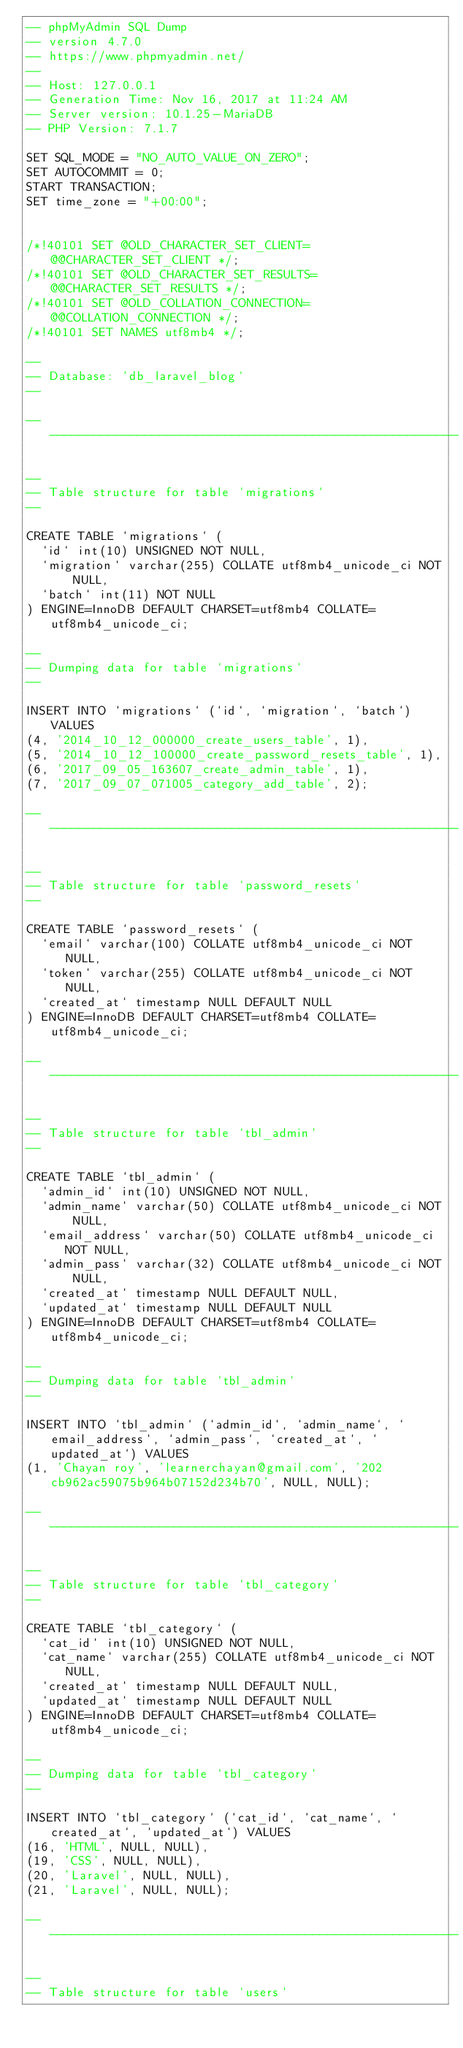<code> <loc_0><loc_0><loc_500><loc_500><_SQL_>-- phpMyAdmin SQL Dump
-- version 4.7.0
-- https://www.phpmyadmin.net/
--
-- Host: 127.0.0.1
-- Generation Time: Nov 16, 2017 at 11:24 AM
-- Server version: 10.1.25-MariaDB
-- PHP Version: 7.1.7

SET SQL_MODE = "NO_AUTO_VALUE_ON_ZERO";
SET AUTOCOMMIT = 0;
START TRANSACTION;
SET time_zone = "+00:00";


/*!40101 SET @OLD_CHARACTER_SET_CLIENT=@@CHARACTER_SET_CLIENT */;
/*!40101 SET @OLD_CHARACTER_SET_RESULTS=@@CHARACTER_SET_RESULTS */;
/*!40101 SET @OLD_COLLATION_CONNECTION=@@COLLATION_CONNECTION */;
/*!40101 SET NAMES utf8mb4 */;

--
-- Database: `db_laravel_blog`
--

-- --------------------------------------------------------

--
-- Table structure for table `migrations`
--

CREATE TABLE `migrations` (
  `id` int(10) UNSIGNED NOT NULL,
  `migration` varchar(255) COLLATE utf8mb4_unicode_ci NOT NULL,
  `batch` int(11) NOT NULL
) ENGINE=InnoDB DEFAULT CHARSET=utf8mb4 COLLATE=utf8mb4_unicode_ci;

--
-- Dumping data for table `migrations`
--

INSERT INTO `migrations` (`id`, `migration`, `batch`) VALUES
(4, '2014_10_12_000000_create_users_table', 1),
(5, '2014_10_12_100000_create_password_resets_table', 1),
(6, '2017_09_05_163607_create_admin_table', 1),
(7, '2017_09_07_071005_category_add_table', 2);

-- --------------------------------------------------------

--
-- Table structure for table `password_resets`
--

CREATE TABLE `password_resets` (
  `email` varchar(100) COLLATE utf8mb4_unicode_ci NOT NULL,
  `token` varchar(255) COLLATE utf8mb4_unicode_ci NOT NULL,
  `created_at` timestamp NULL DEFAULT NULL
) ENGINE=InnoDB DEFAULT CHARSET=utf8mb4 COLLATE=utf8mb4_unicode_ci;

-- --------------------------------------------------------

--
-- Table structure for table `tbl_admin`
--

CREATE TABLE `tbl_admin` (
  `admin_id` int(10) UNSIGNED NOT NULL,
  `admin_name` varchar(50) COLLATE utf8mb4_unicode_ci NOT NULL,
  `email_address` varchar(50) COLLATE utf8mb4_unicode_ci NOT NULL,
  `admin_pass` varchar(32) COLLATE utf8mb4_unicode_ci NOT NULL,
  `created_at` timestamp NULL DEFAULT NULL,
  `updated_at` timestamp NULL DEFAULT NULL
) ENGINE=InnoDB DEFAULT CHARSET=utf8mb4 COLLATE=utf8mb4_unicode_ci;

--
-- Dumping data for table `tbl_admin`
--

INSERT INTO `tbl_admin` (`admin_id`, `admin_name`, `email_address`, `admin_pass`, `created_at`, `updated_at`) VALUES
(1, 'Chayan roy', 'learnerchayan@gmail.com', '202cb962ac59075b964b07152d234b70', NULL, NULL);

-- --------------------------------------------------------

--
-- Table structure for table `tbl_category`
--

CREATE TABLE `tbl_category` (
  `cat_id` int(10) UNSIGNED NOT NULL,
  `cat_name` varchar(255) COLLATE utf8mb4_unicode_ci NOT NULL,
  `created_at` timestamp NULL DEFAULT NULL,
  `updated_at` timestamp NULL DEFAULT NULL
) ENGINE=InnoDB DEFAULT CHARSET=utf8mb4 COLLATE=utf8mb4_unicode_ci;

--
-- Dumping data for table `tbl_category`
--

INSERT INTO `tbl_category` (`cat_id`, `cat_name`, `created_at`, `updated_at`) VALUES
(16, 'HTML', NULL, NULL),
(19, 'CSS', NULL, NULL),
(20, 'Laravel', NULL, NULL),
(21, 'Laravel', NULL, NULL);

-- --------------------------------------------------------

--
-- Table structure for table `users`</code> 